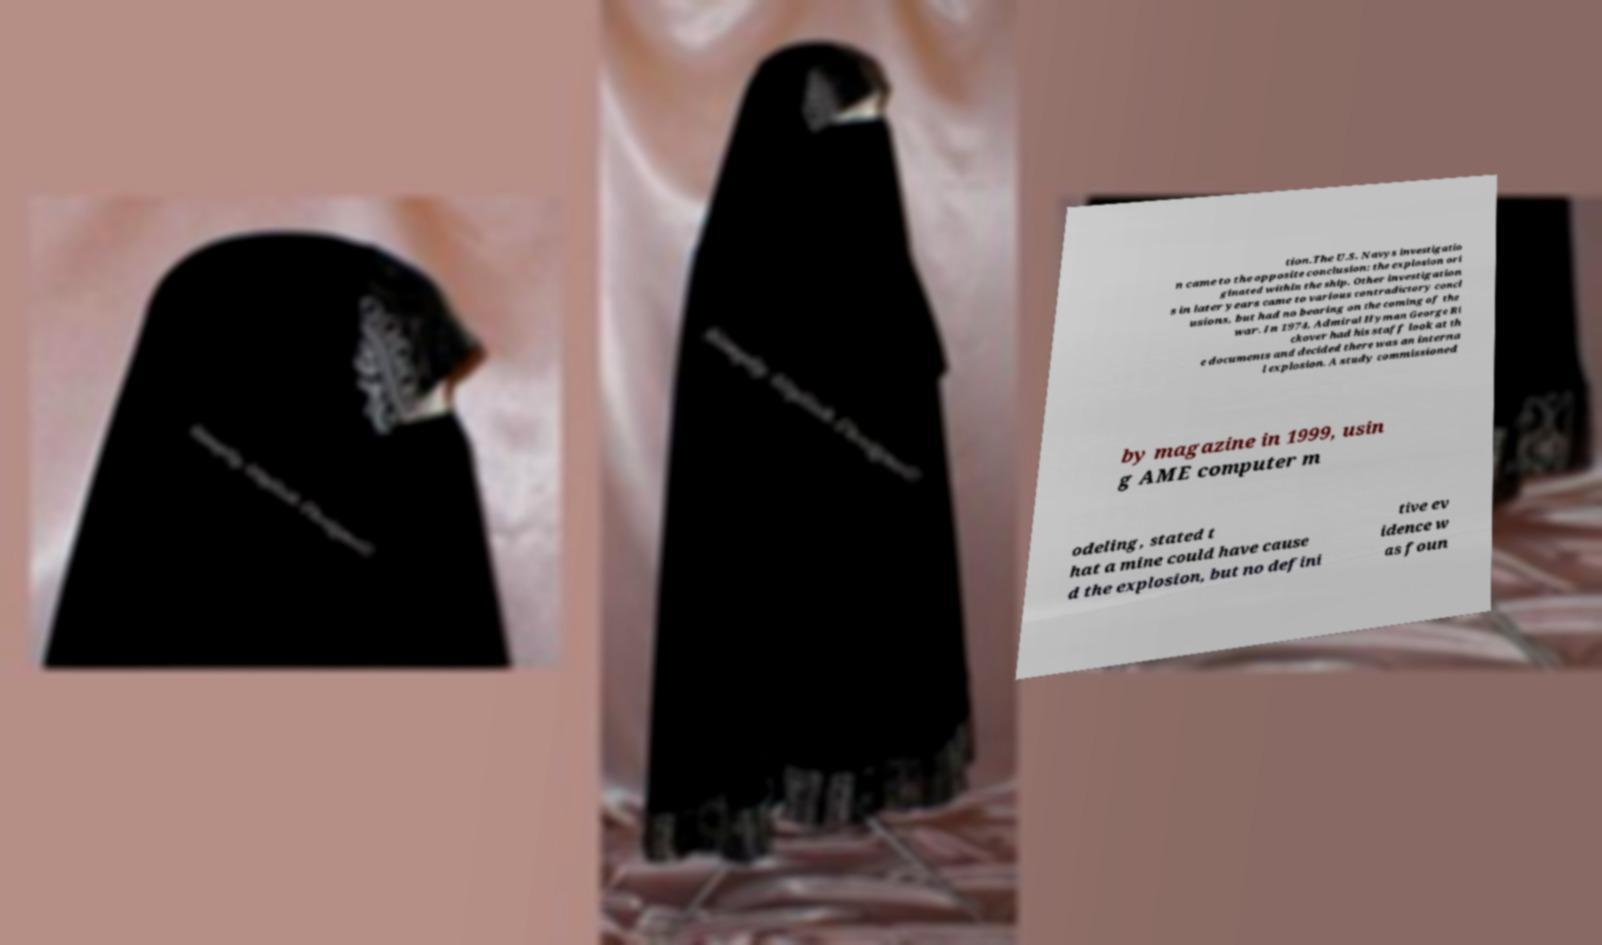Please read and relay the text visible in this image. What does it say? tion.The U.S. Navys investigatio n came to the opposite conclusion: the explosion ori ginated within the ship. Other investigation s in later years came to various contradictory concl usions, but had no bearing on the coming of the war. In 1974, Admiral Hyman George Ri ckover had his staff look at th e documents and decided there was an interna l explosion. A study commissioned by magazine in 1999, usin g AME computer m odeling, stated t hat a mine could have cause d the explosion, but no defini tive ev idence w as foun 